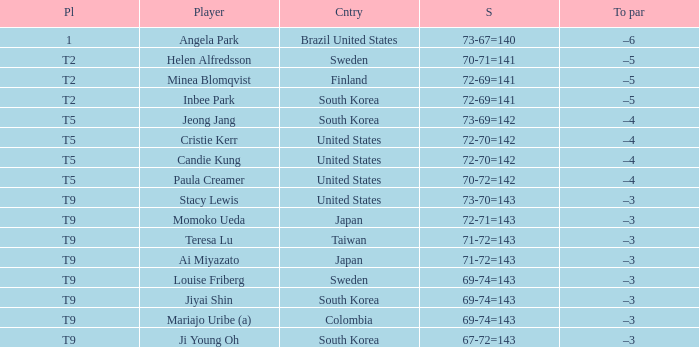Who placed t5 and had a score of 70-72=142? Paula Creamer. 